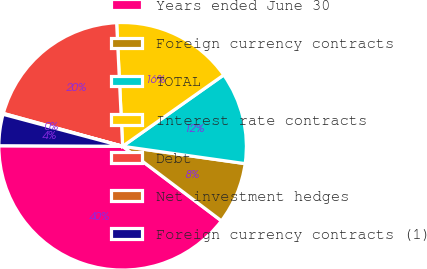<chart> <loc_0><loc_0><loc_500><loc_500><pie_chart><fcel>Years ended June 30<fcel>Foreign currency contracts<fcel>TOTAL<fcel>Interest rate contracts<fcel>Debt<fcel>Net investment hedges<fcel>Foreign currency contracts (1)<nl><fcel>39.79%<fcel>8.05%<fcel>12.02%<fcel>15.99%<fcel>19.95%<fcel>0.12%<fcel>4.09%<nl></chart> 